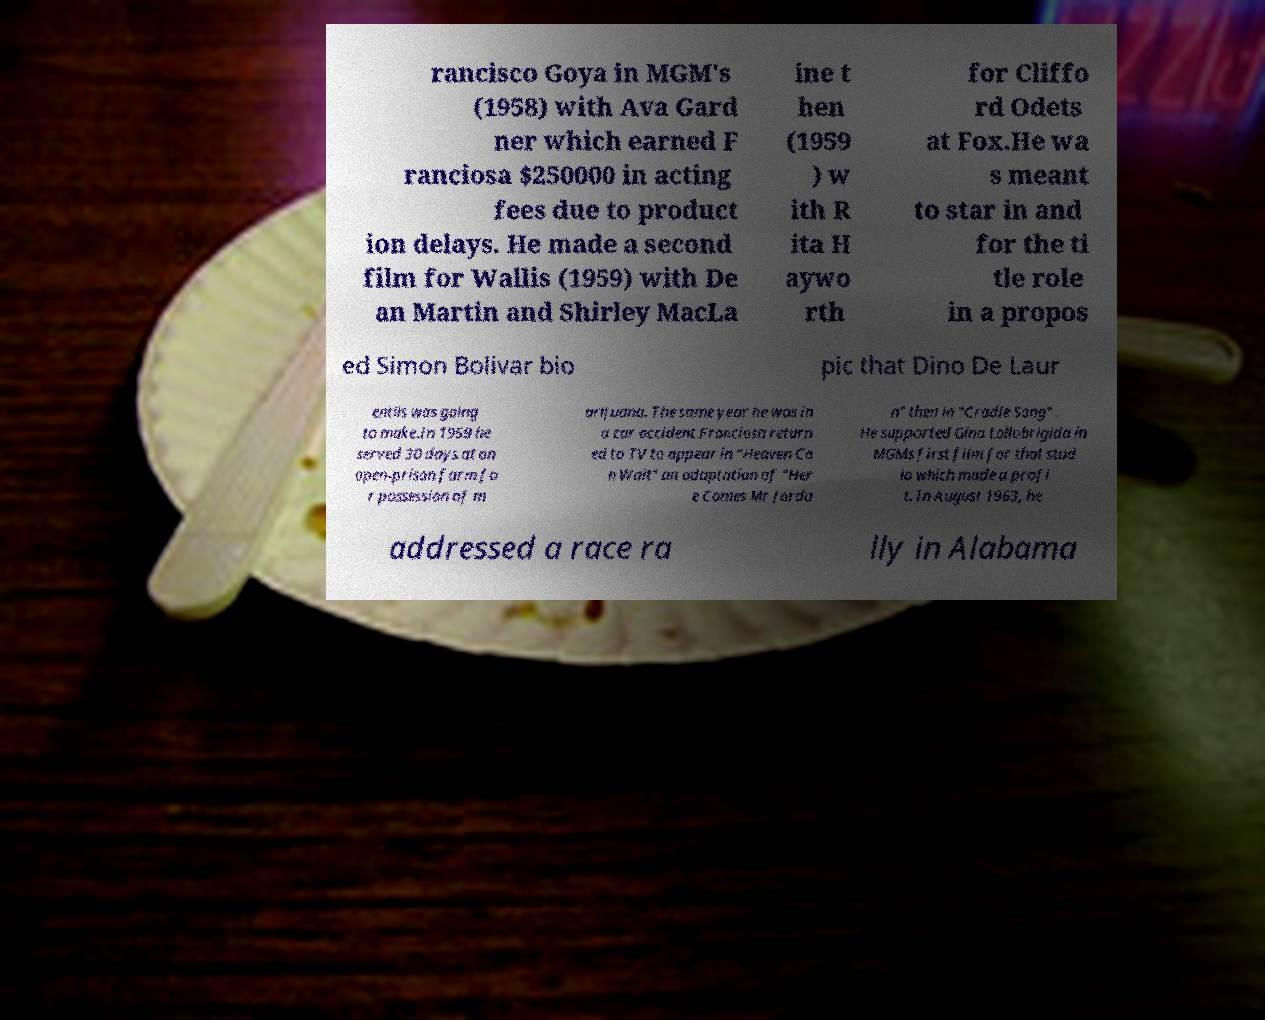Can you read and provide the text displayed in the image?This photo seems to have some interesting text. Can you extract and type it out for me? rancisco Goya in MGM's (1958) with Ava Gard ner which earned F ranciosa $250000 in acting fees due to product ion delays. He made a second film for Wallis (1959) with De an Martin and Shirley MacLa ine t hen (1959 ) w ith R ita H aywo rth for Cliffo rd Odets at Fox.He wa s meant to star in and for the ti tle role in a propos ed Simon Bolivar bio pic that Dino De Laur entiis was going to make.In 1959 he served 30 days at an open-prison farm fo r possession of m arijuana. The same year he was in a car accident.Franciosa return ed to TV to appear in "Heaven Ca n Wait" an adaptation of "Her e Comes Mr Jorda n" then in "Cradle Song" . He supported Gina Lollobrigida in MGMs first film for that stud io which made a profi t. In August 1963, he addressed a race ra lly in Alabama 